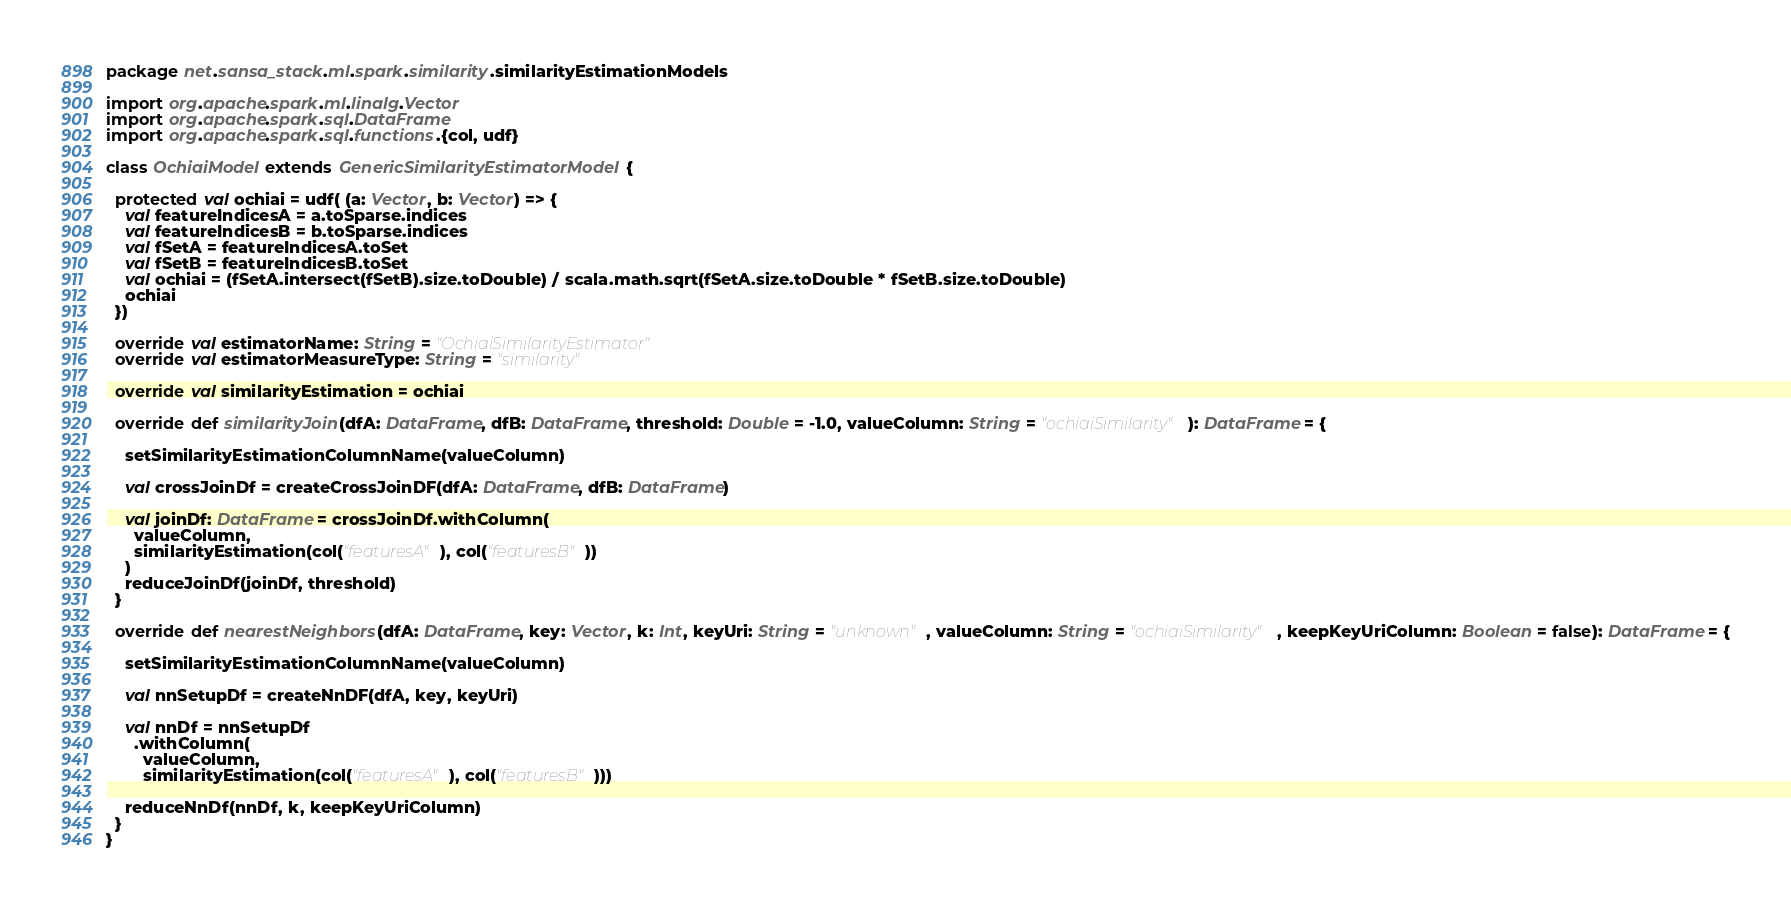Convert code to text. <code><loc_0><loc_0><loc_500><loc_500><_Scala_>package net.sansa_stack.ml.spark.similarity.similarityEstimationModels

import org.apache.spark.ml.linalg.Vector
import org.apache.spark.sql.DataFrame
import org.apache.spark.sql.functions.{col, udf}

class OchiaiModel extends GenericSimilarityEstimatorModel {

  protected val ochiai = udf( (a: Vector, b: Vector) => {
    val featureIndicesA = a.toSparse.indices
    val featureIndicesB = b.toSparse.indices
    val fSetA = featureIndicesA.toSet
    val fSetB = featureIndicesB.toSet
    val ochiai = (fSetA.intersect(fSetB).size.toDouble) / scala.math.sqrt(fSetA.size.toDouble * fSetB.size.toDouble)
    ochiai
  })

  override val estimatorName: String = "OchiaiSimilarityEstimator"
  override val estimatorMeasureType: String = "similarity"

  override val similarityEstimation = ochiai

  override def similarityJoin(dfA: DataFrame, dfB: DataFrame, threshold: Double = -1.0, valueColumn: String = "ochiaiSimilarity"): DataFrame = {

    setSimilarityEstimationColumnName(valueColumn)

    val crossJoinDf = createCrossJoinDF(dfA: DataFrame, dfB: DataFrame)

    val joinDf: DataFrame = crossJoinDf.withColumn(
      valueColumn,
      similarityEstimation(col("featuresA"), col("featuresB"))
    )
    reduceJoinDf(joinDf, threshold)
  }

  override def nearestNeighbors(dfA: DataFrame, key: Vector, k: Int, keyUri: String = "unknown", valueColumn: String = "ochiaiSimilarity", keepKeyUriColumn: Boolean = false): DataFrame = {

    setSimilarityEstimationColumnName(valueColumn)

    val nnSetupDf = createNnDF(dfA, key, keyUri)

    val nnDf = nnSetupDf
      .withColumn(
        valueColumn,
        similarityEstimation(col("featuresA"), col("featuresB")))

    reduceNnDf(nnDf, k, keepKeyUriColumn)
  }
}
</code> 